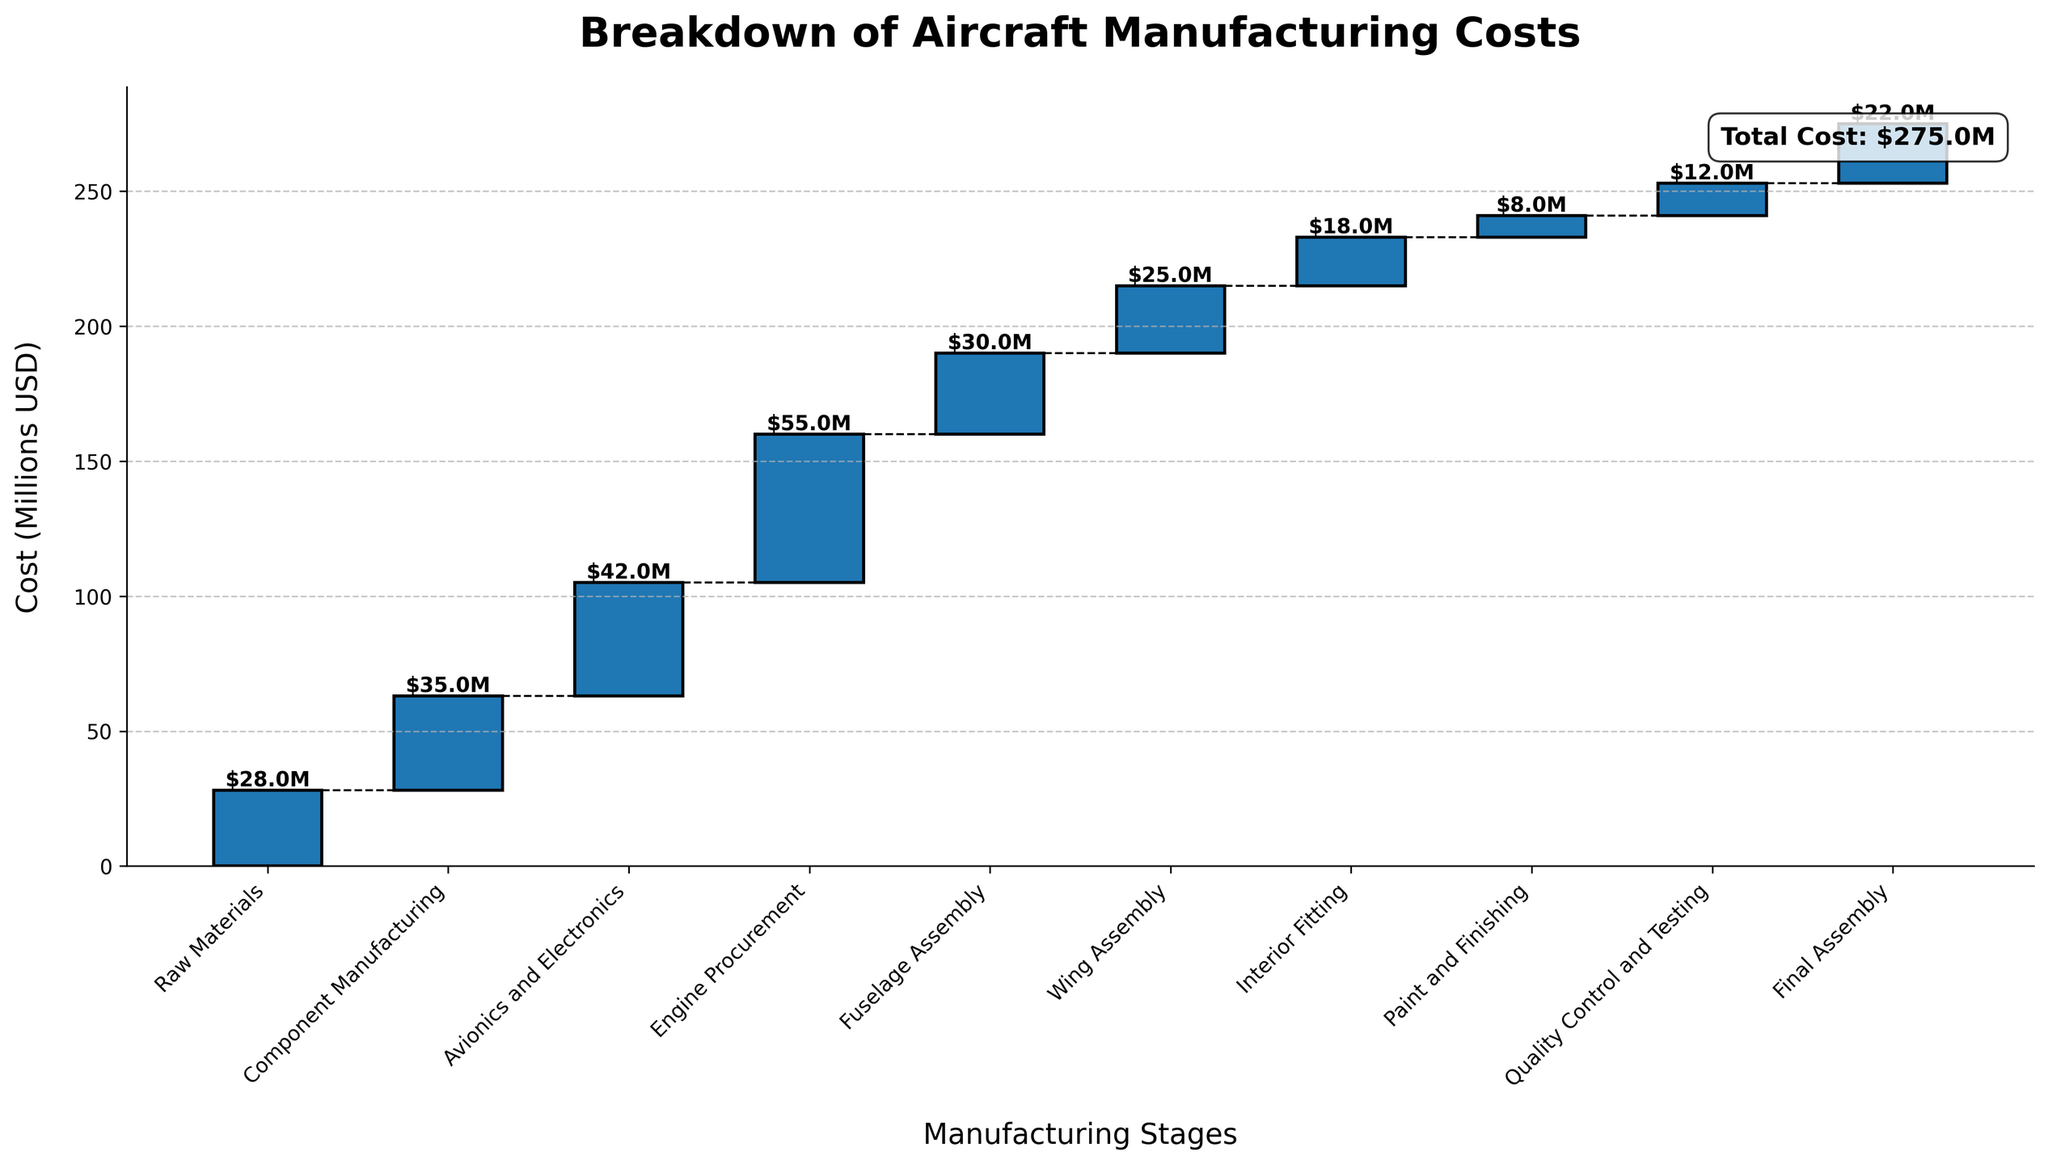What is the total manufacturing cost indicated in the chart? The total manufacturing cost is shown in a text box at the top right corner of the chart. It mentions the total cost.
Answer: $275M Which manufacturing stage incurs the highest cost? To find the highest cost, look at the vertical height of each bar. The tallest bar corresponds to the stage with the highest cost.
Answer: Engine Procurement How much does Raw Materials and Component Manufacturing together contribute to the total cost? Add the values of Raw Materials and Component Manufacturing stages. Raw Materials = $28M, Component Manufacturing = $35M, so $28M + $35M.
Answer: $63M Does Paint and Finishing cost more or less than Quality Control and Testing? Compare the heights of the Paint and Finishing bar and the Quality Control and Testing bar.
Answer: Less What is the combined cost of Avionics and Electronics and Wing Assembly? Add the values of Avionics and Electronics and Wing Assembly stages. Avionics and Electronics = $42M, Wing Assembly = $25M, so $42M + $25M.
Answer: $67M Which stage incurs the lowest cost, and what is its value? Identify the shortest bar in the chart. The shortest bar indicates the lowest cost.
Answer: Paint and Finishing, $8M What manufacturing stage occurs directly after Wing Assembly? From the x-axis labels, find the stage listed immediately after Wing Assembly.
Answer: Interior Fitting By how much does the component manufacturing cost exceed the cost of final assembly? Subtract the cost of Final Assembly from the cost of Component Manufacturing. Component Manufacturing = $35M, Final Assembly = $22M, so $35M - $22M.
Answer: $13M What is the cumulative cost up to Fuselage Assembly? Sum the costs up to and including Fuselage Assembly. Raw Materials = $28M, Component Manufacturing = $35M, Avionics and Electronics = $42M, Engine Procurement = $55M, Fuselage Assembly = $30M. $28M + $35M + $42M + $55M + $30M.
Answer: $190M 